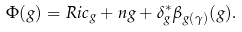Convert formula to latex. <formula><loc_0><loc_0><loc_500><loc_500>\Phi ( g ) = R i c _ { g } + n g + \delta _ { g } ^ { * } \beta _ { g ( \gamma ) } ( g ) .</formula> 